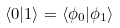Convert formula to latex. <formula><loc_0><loc_0><loc_500><loc_500>\langle 0 | 1 \rangle = \langle \phi _ { 0 } | \phi _ { 1 } \rangle</formula> 